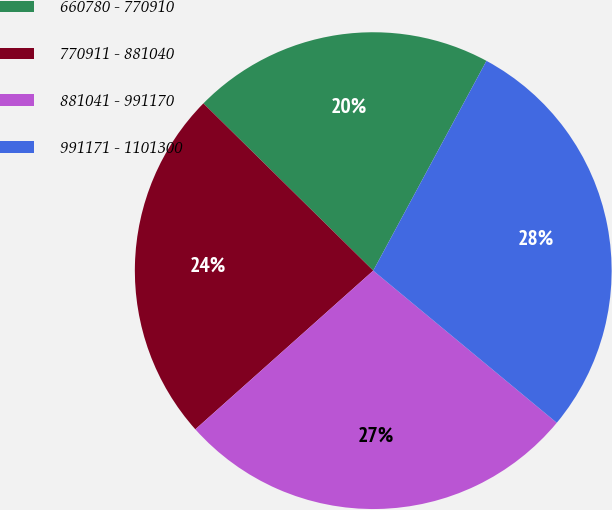Convert chart to OTSL. <chart><loc_0><loc_0><loc_500><loc_500><pie_chart><fcel>660780 - 770910<fcel>770911 - 881040<fcel>881041 - 991170<fcel>991171 - 1101300<nl><fcel>20.5%<fcel>23.97%<fcel>27.39%<fcel>28.14%<nl></chart> 